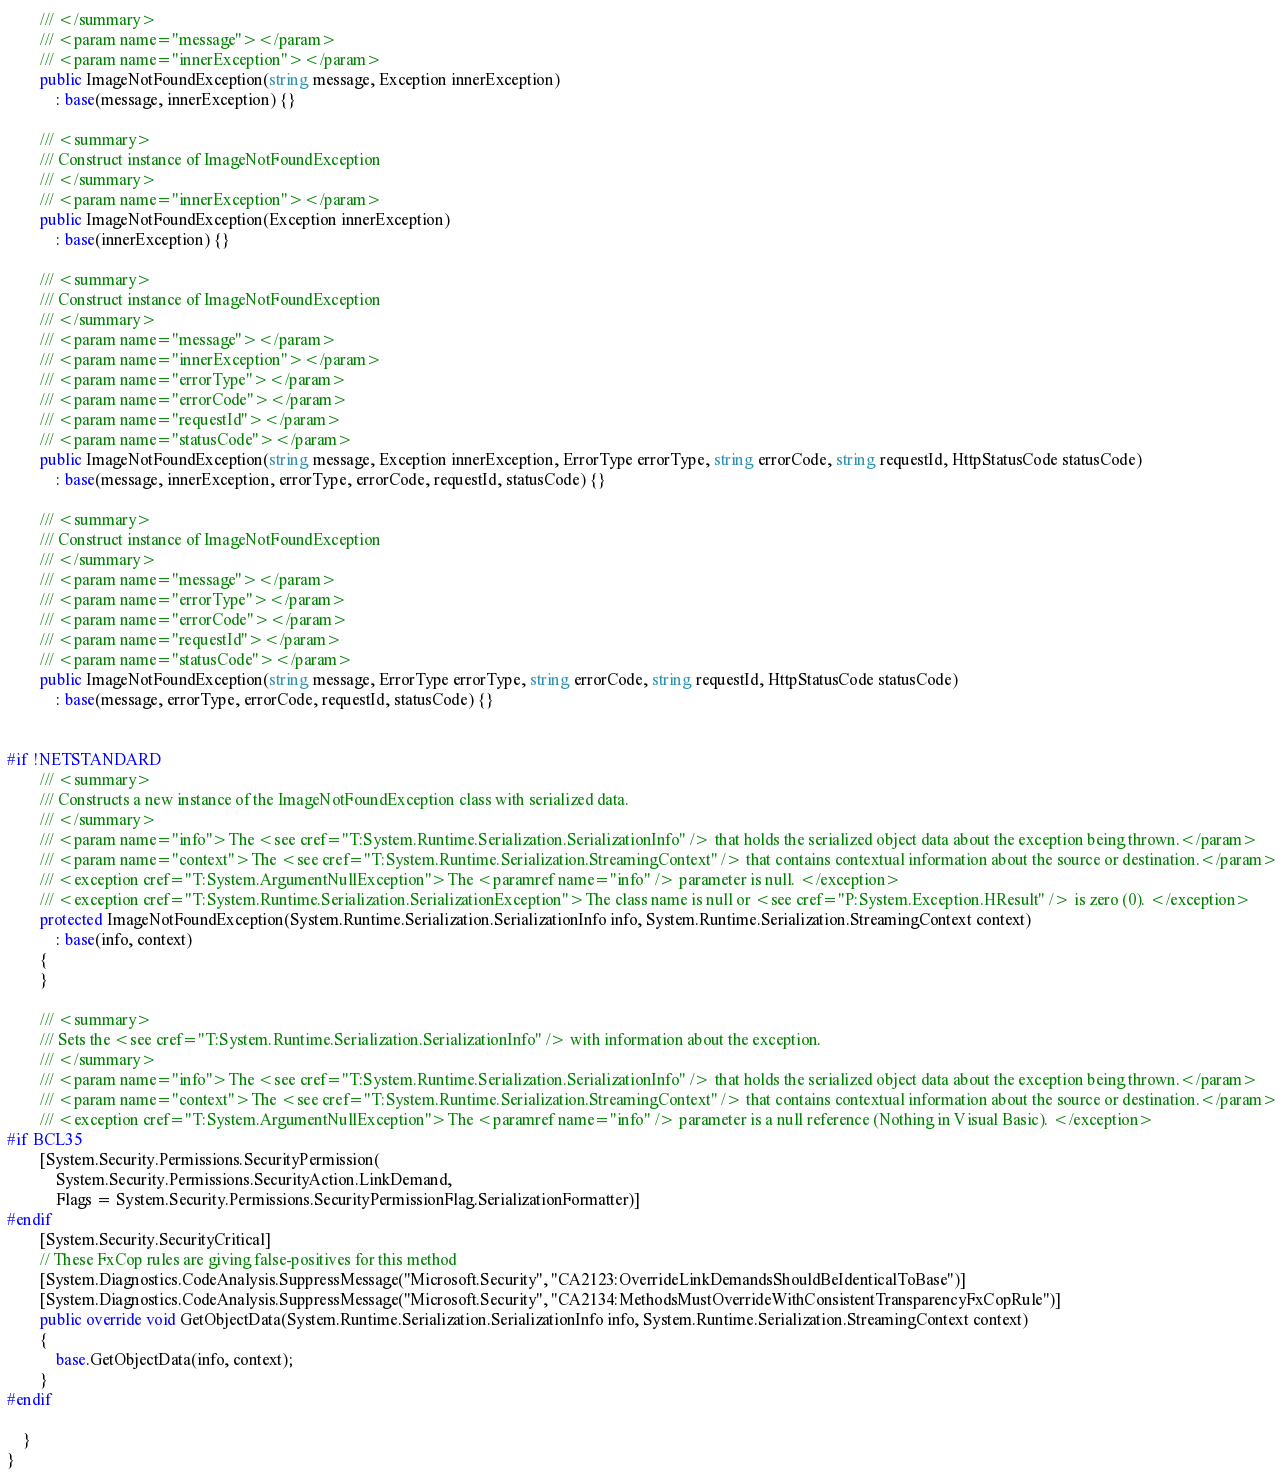Convert code to text. <code><loc_0><loc_0><loc_500><loc_500><_C#_>        /// </summary>
        /// <param name="message"></param>
        /// <param name="innerException"></param>
        public ImageNotFoundException(string message, Exception innerException) 
            : base(message, innerException) {}

        /// <summary>
        /// Construct instance of ImageNotFoundException
        /// </summary>
        /// <param name="innerException"></param>
        public ImageNotFoundException(Exception innerException) 
            : base(innerException) {}

        /// <summary>
        /// Construct instance of ImageNotFoundException
        /// </summary>
        /// <param name="message"></param>
        /// <param name="innerException"></param>
        /// <param name="errorType"></param>
        /// <param name="errorCode"></param>
        /// <param name="requestId"></param>
        /// <param name="statusCode"></param>
        public ImageNotFoundException(string message, Exception innerException, ErrorType errorType, string errorCode, string requestId, HttpStatusCode statusCode) 
            : base(message, innerException, errorType, errorCode, requestId, statusCode) {}

        /// <summary>
        /// Construct instance of ImageNotFoundException
        /// </summary>
        /// <param name="message"></param>
        /// <param name="errorType"></param>
        /// <param name="errorCode"></param>
        /// <param name="requestId"></param>
        /// <param name="statusCode"></param>
        public ImageNotFoundException(string message, ErrorType errorType, string errorCode, string requestId, HttpStatusCode statusCode) 
            : base(message, errorType, errorCode, requestId, statusCode) {}


#if !NETSTANDARD
        /// <summary>
        /// Constructs a new instance of the ImageNotFoundException class with serialized data.
        /// </summary>
        /// <param name="info">The <see cref="T:System.Runtime.Serialization.SerializationInfo" /> that holds the serialized object data about the exception being thrown.</param>
        /// <param name="context">The <see cref="T:System.Runtime.Serialization.StreamingContext" /> that contains contextual information about the source or destination.</param>
        /// <exception cref="T:System.ArgumentNullException">The <paramref name="info" /> parameter is null. </exception>
        /// <exception cref="T:System.Runtime.Serialization.SerializationException">The class name is null or <see cref="P:System.Exception.HResult" /> is zero (0). </exception>
        protected ImageNotFoundException(System.Runtime.Serialization.SerializationInfo info, System.Runtime.Serialization.StreamingContext context)
            : base(info, context)
        {
        }

        /// <summary>
        /// Sets the <see cref="T:System.Runtime.Serialization.SerializationInfo" /> with information about the exception.
        /// </summary>
        /// <param name="info">The <see cref="T:System.Runtime.Serialization.SerializationInfo" /> that holds the serialized object data about the exception being thrown.</param>
        /// <param name="context">The <see cref="T:System.Runtime.Serialization.StreamingContext" /> that contains contextual information about the source or destination.</param>
        /// <exception cref="T:System.ArgumentNullException">The <paramref name="info" /> parameter is a null reference (Nothing in Visual Basic). </exception>
#if BCL35
        [System.Security.Permissions.SecurityPermission(
            System.Security.Permissions.SecurityAction.LinkDemand,
            Flags = System.Security.Permissions.SecurityPermissionFlag.SerializationFormatter)]
#endif
        [System.Security.SecurityCritical]
        // These FxCop rules are giving false-positives for this method
        [System.Diagnostics.CodeAnalysis.SuppressMessage("Microsoft.Security", "CA2123:OverrideLinkDemandsShouldBeIdenticalToBase")]
        [System.Diagnostics.CodeAnalysis.SuppressMessage("Microsoft.Security", "CA2134:MethodsMustOverrideWithConsistentTransparencyFxCopRule")]
        public override void GetObjectData(System.Runtime.Serialization.SerializationInfo info, System.Runtime.Serialization.StreamingContext context)
        {
            base.GetObjectData(info, context);
        }
#endif

    }
}</code> 